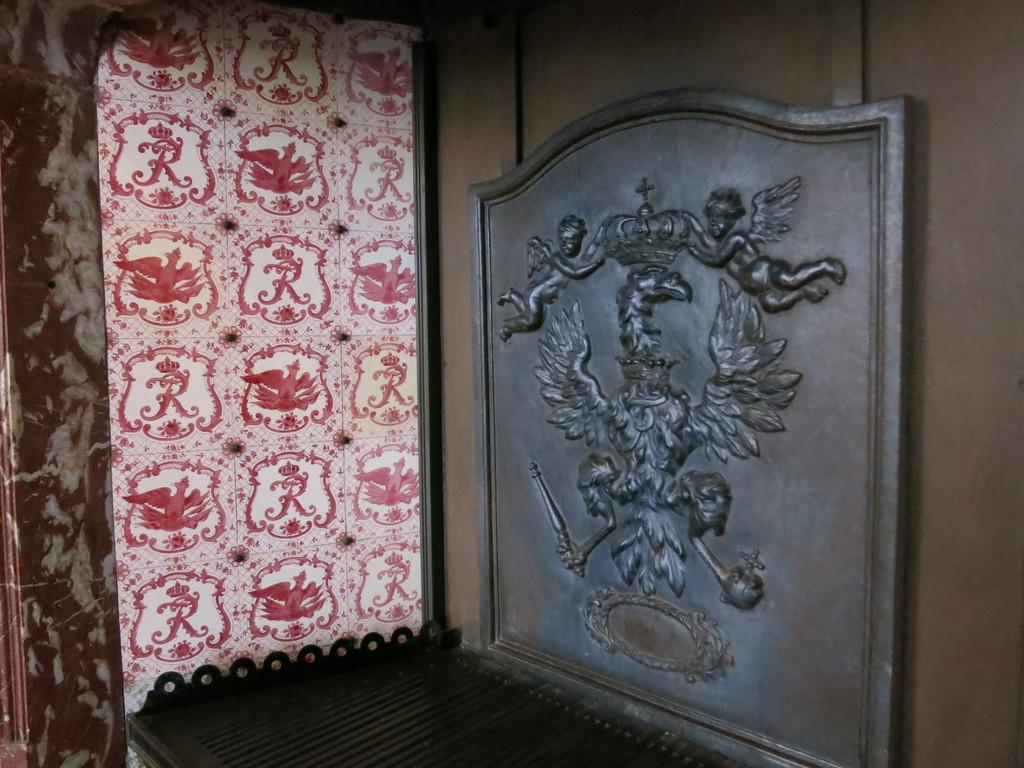What can be seen on the wall in the image? There is a sculpture on a wall in the image. On which side of the image is the sculpture located? The sculpture is on the right side of the image. What is present on the left side of the image? There is a curtain in the image. Where is the curtain positioned in relation to the sculpture? The curtain is on the left side of the image. What type of produce is being sold on the slope in the image? There is no produce or slope present in the image; it features a sculpture on a wall and a curtain on the left side. 